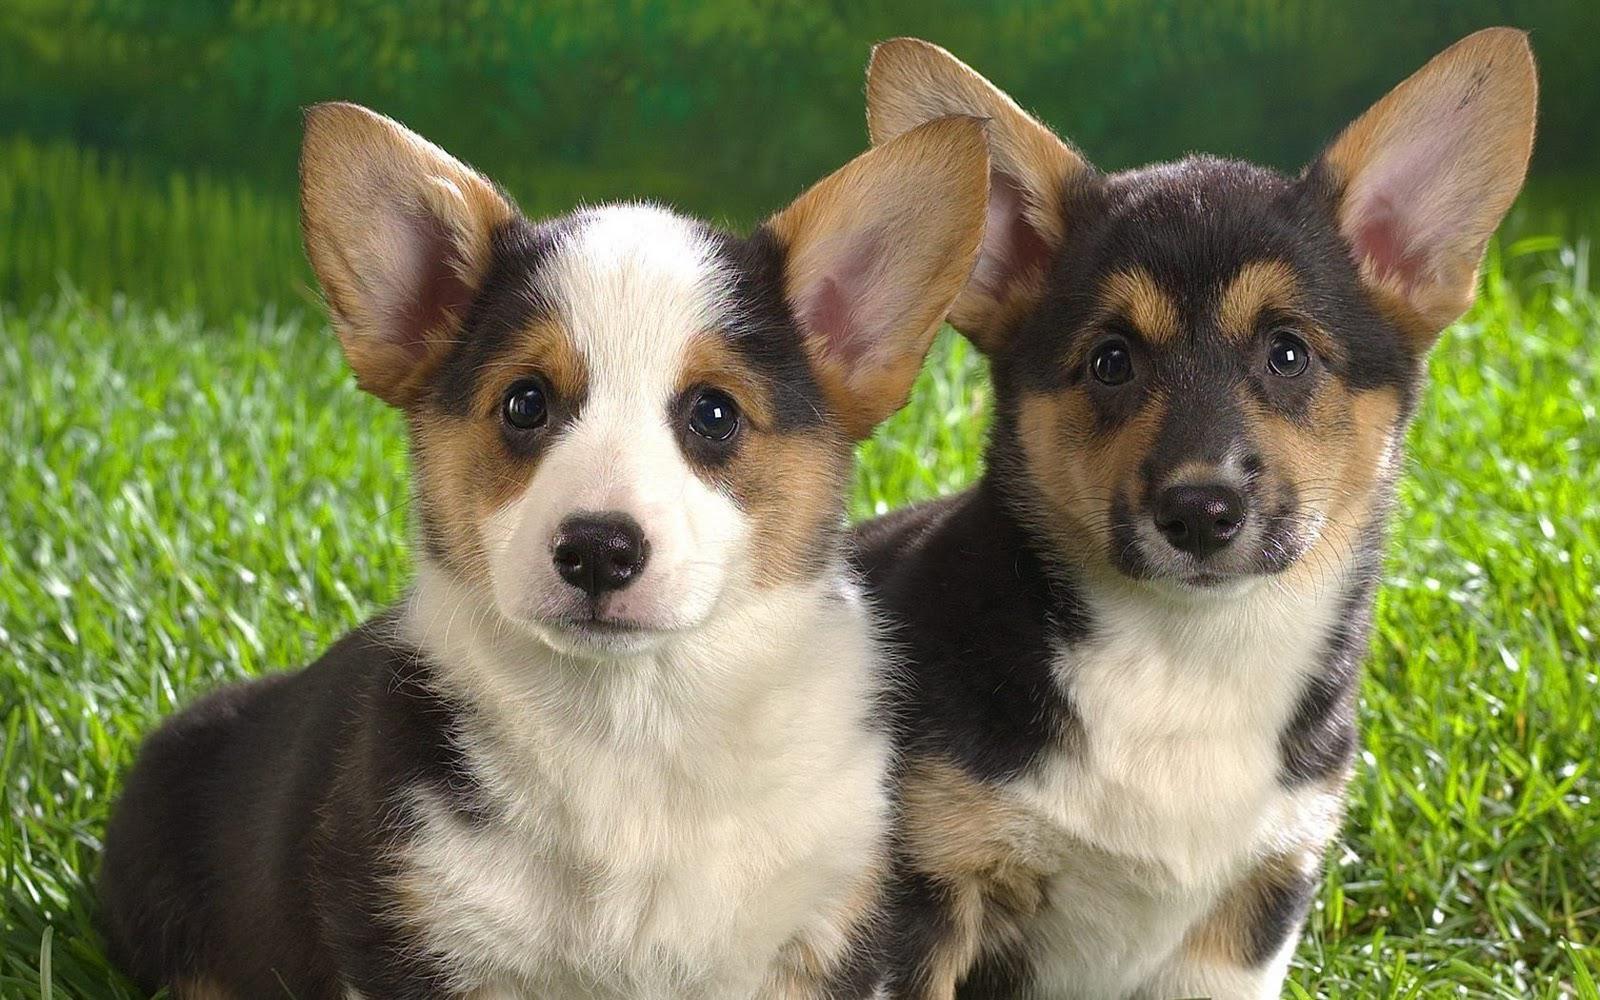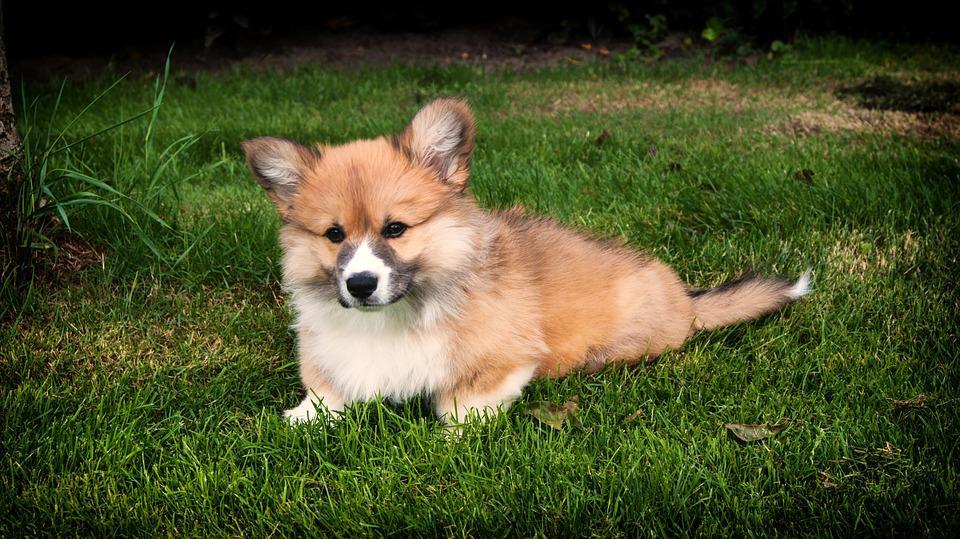The first image is the image on the left, the second image is the image on the right. Assess this claim about the two images: "Two tan and white dogs have short legs and upright ears.". Correct or not? Answer yes or no. No. The first image is the image on the left, the second image is the image on the right. Assess this claim about the two images: "There is a tri-colored dog with a black mask look.". Correct or not? Answer yes or no. Yes. 